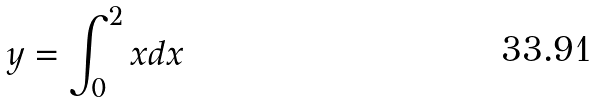<formula> <loc_0><loc_0><loc_500><loc_500>y = \int _ { 0 } ^ { 2 } x d x</formula> 